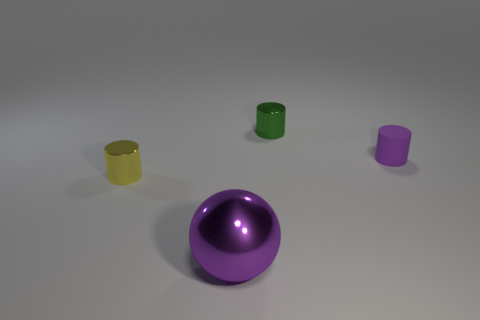The tiny green object that is the same material as the big sphere is what shape?
Give a very brief answer. Cylinder. There is a tiny cylinder that is to the left of the metal cylinder behind the tiny rubber object; what is its color?
Make the answer very short. Yellow. Is the color of the rubber object the same as the large object?
Make the answer very short. Yes. The tiny thing that is in front of the purple object that is behind the yellow object is made of what material?
Offer a terse response. Metal. There is a small purple object that is the same shape as the small green metallic object; what material is it?
Your answer should be compact. Rubber. There is a small metallic object that is to the right of the small shiny cylinder that is on the left side of the green shiny cylinder; are there any big purple metallic spheres right of it?
Your response must be concise. No. How many other things are there of the same color as the tiny rubber thing?
Make the answer very short. 1. How many tiny things are both right of the green metallic cylinder and to the left of the small purple cylinder?
Provide a short and direct response. 0. What is the shape of the tiny matte object?
Your response must be concise. Cylinder. How many other things are made of the same material as the large sphere?
Give a very brief answer. 2. 